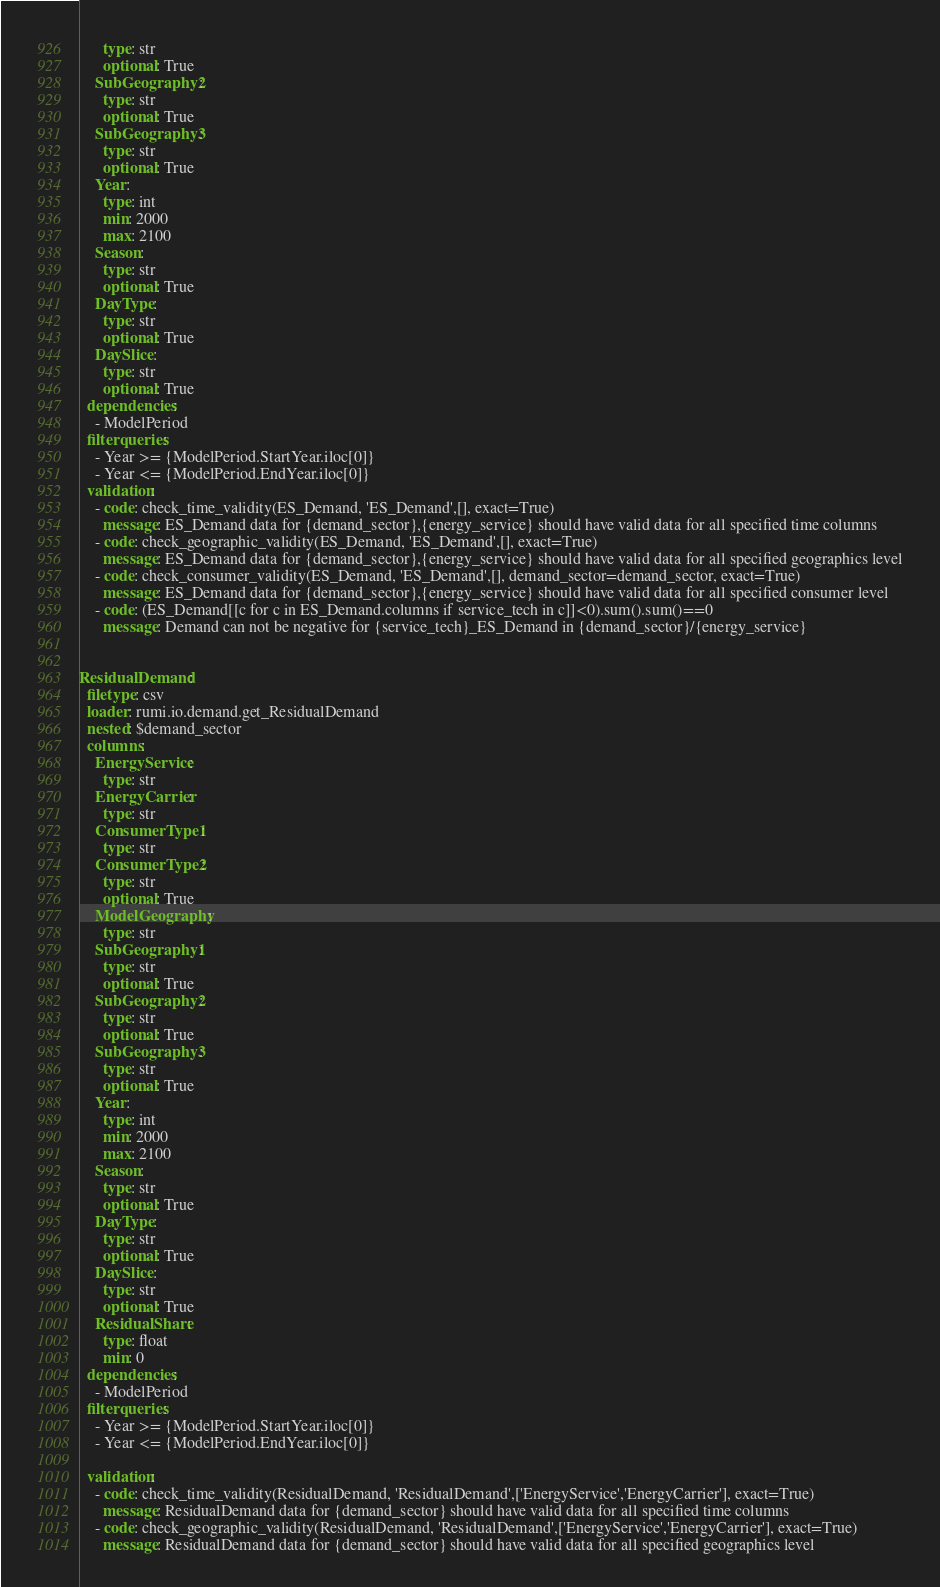Convert code to text. <code><loc_0><loc_0><loc_500><loc_500><_YAML_>      type: str
      optional: True
    SubGeography2:
      type: str
      optional: True
    SubGeography3:
      type: str
      optional: True
    Year:
      type: int
      min: 2000
      max: 2100
    Season:
      type: str
      optional: True
    DayType:
      type: str
      optional: True
    DaySlice:
      type: str
      optional: True
  dependencies:
    - ModelPeriod
  filterqueries:
    - Year >= {ModelPeriod.StartYear.iloc[0]}
    - Year <= {ModelPeriod.EndYear.iloc[0]}
  validation:
    - code: check_time_validity(ES_Demand, 'ES_Demand',[], exact=True)
      message: ES_Demand data for {demand_sector},{energy_service} should have valid data for all specified time columns
    - code: check_geographic_validity(ES_Demand, 'ES_Demand',[], exact=True)
      message: ES_Demand data for {demand_sector},{energy_service} should have valid data for all specified geographics level
    - code: check_consumer_validity(ES_Demand, 'ES_Demand',[], demand_sector=demand_sector, exact=True)
      message: ES_Demand data for {demand_sector},{energy_service} should have valid data for all specified consumer level
    - code: (ES_Demand[[c for c in ES_Demand.columns if service_tech in c]]<0).sum().sum()==0
      message: Demand can not be negative for {service_tech}_ES_Demand in {demand_sector}/{energy_service}

      
ResidualDemand:
  filetype: csv
  loader: rumi.io.demand.get_ResidualDemand
  nested: $demand_sector
  columns:
    EnergyService:
      type: str
    EnergyCarrier:
      type: str
    ConsumerType1:
      type: str
    ConsumerType2:
      type: str
      optional: True
    ModelGeography:
      type: str
    SubGeography1:
      type: str
      optional: True
    SubGeography2:
      type: str
      optional: True
    SubGeography3:
      type: str
      optional: True
    Year:
      type: int
      min: 2000
      max: 2100
    Season:
      type: str
      optional: True
    DayType:
      type: str
      optional: True
    DaySlice:
      type: str
      optional: True
    ResidualShare:
      type: float
      min: 0
  dependencies:
    - ModelPeriod
  filterqueries:
    - Year >= {ModelPeriod.StartYear.iloc[0]}
    - Year <= {ModelPeriod.EndYear.iloc[0]}
      
  validation:
    - code: check_time_validity(ResidualDemand, 'ResidualDemand',['EnergyService','EnergyCarrier'], exact=True)
      message: ResidualDemand data for {demand_sector} should have valid data for all specified time columns
    - code: check_geographic_validity(ResidualDemand, 'ResidualDemand',['EnergyService','EnergyCarrier'], exact=True)
      message: ResidualDemand data for {demand_sector} should have valid data for all specified geographics level</code> 